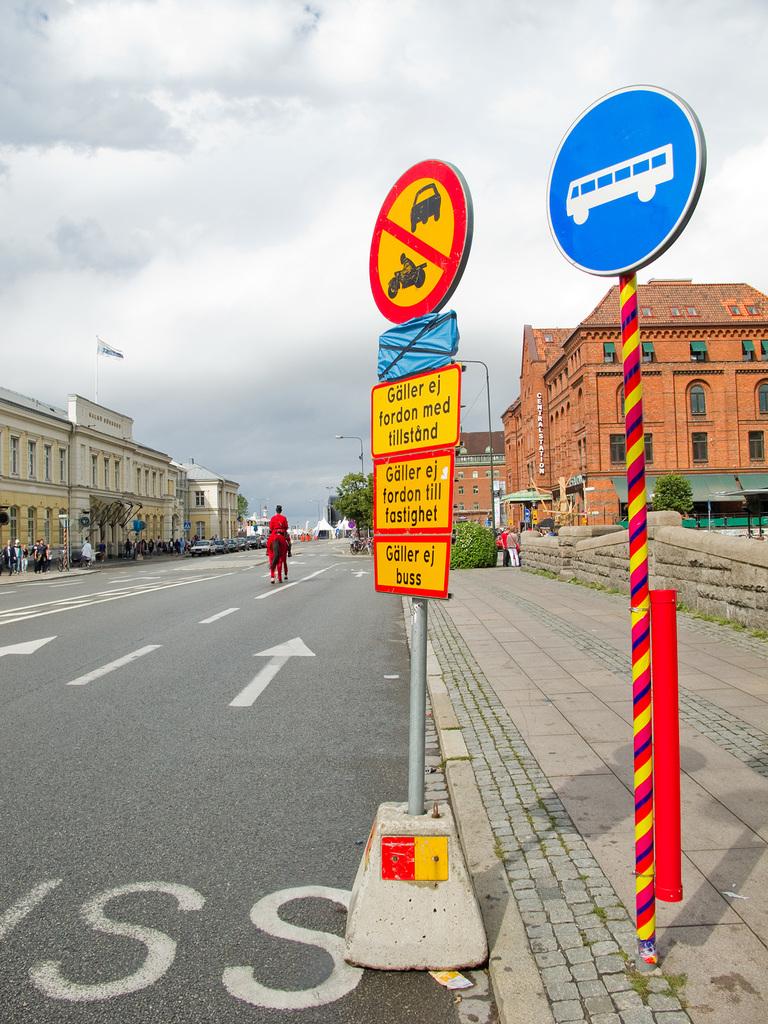What are the letters printed on the road?
Your answer should be compact. Ss. 